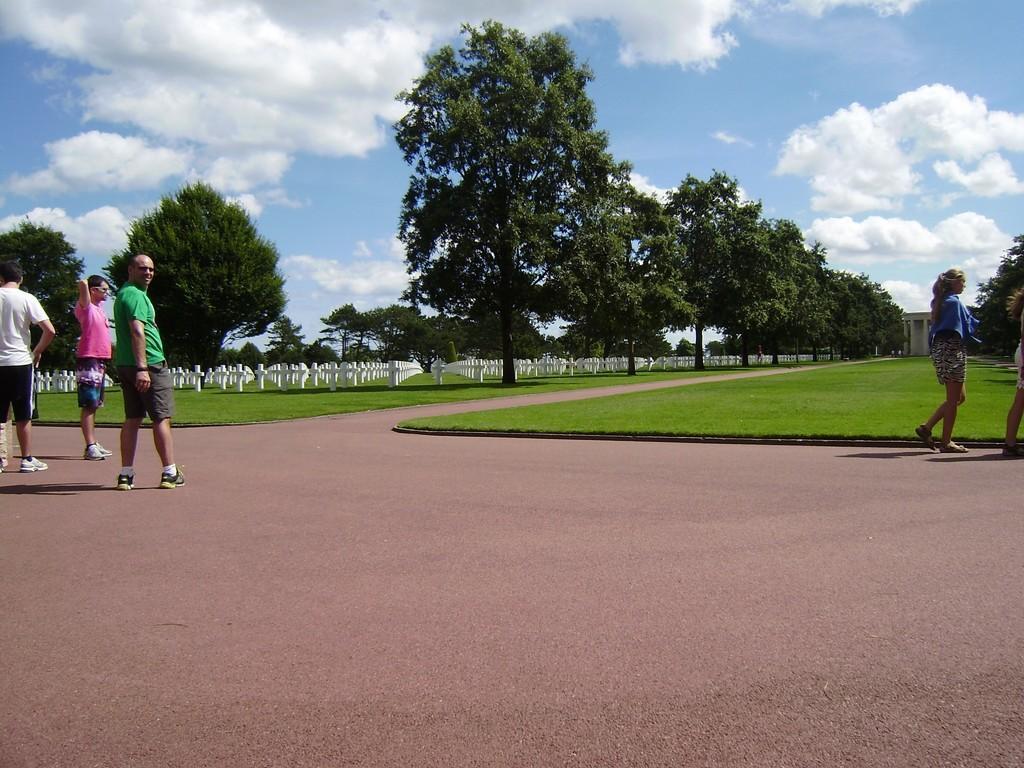Could you give a brief overview of what you see in this image? There are three men standing and a woman walking. This is the grass. I think this is a graveyard. These are the trees. I can see the clouds in the sky. On the very right corner of the image, I can see another woman standing. 